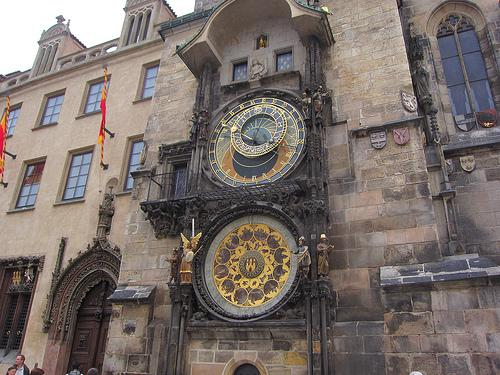Question: why is there a clock?
Choices:
A. To time the test.
B. Give time.
C. To time the runners.
D. To keep track of the class.
Answer with the letter. Answer: B Question: what shape are the left windows?
Choices:
A. Round.
B. Rectangle.
C. Square.
D. Oval.
Answer with the letter. Answer: B 